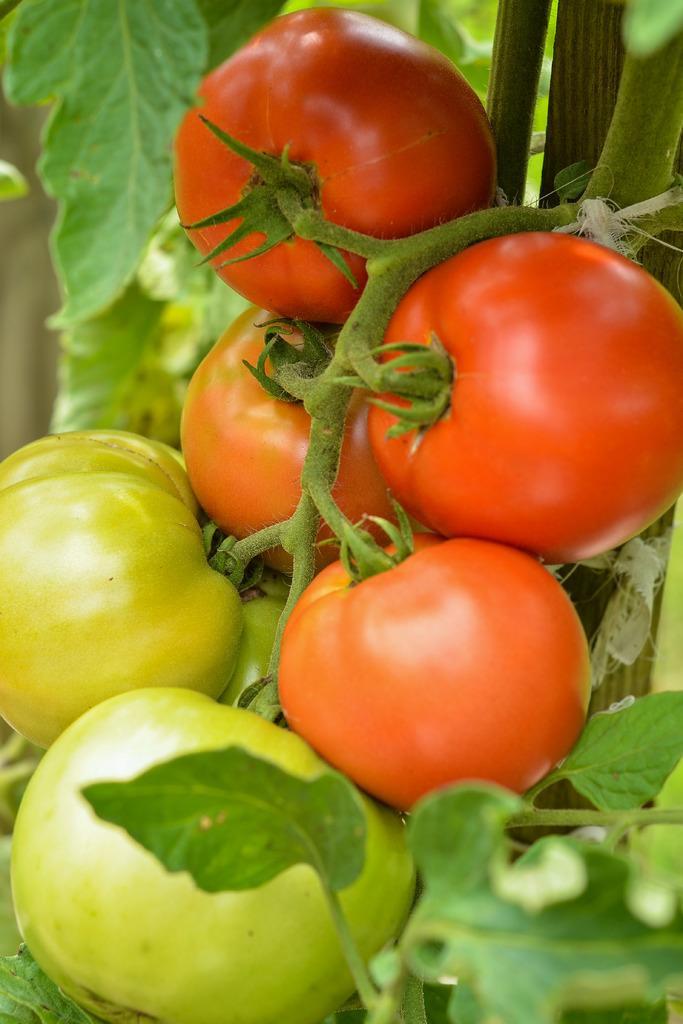Can you describe this image briefly? In this image, we can see some tomatoes and leaves. 